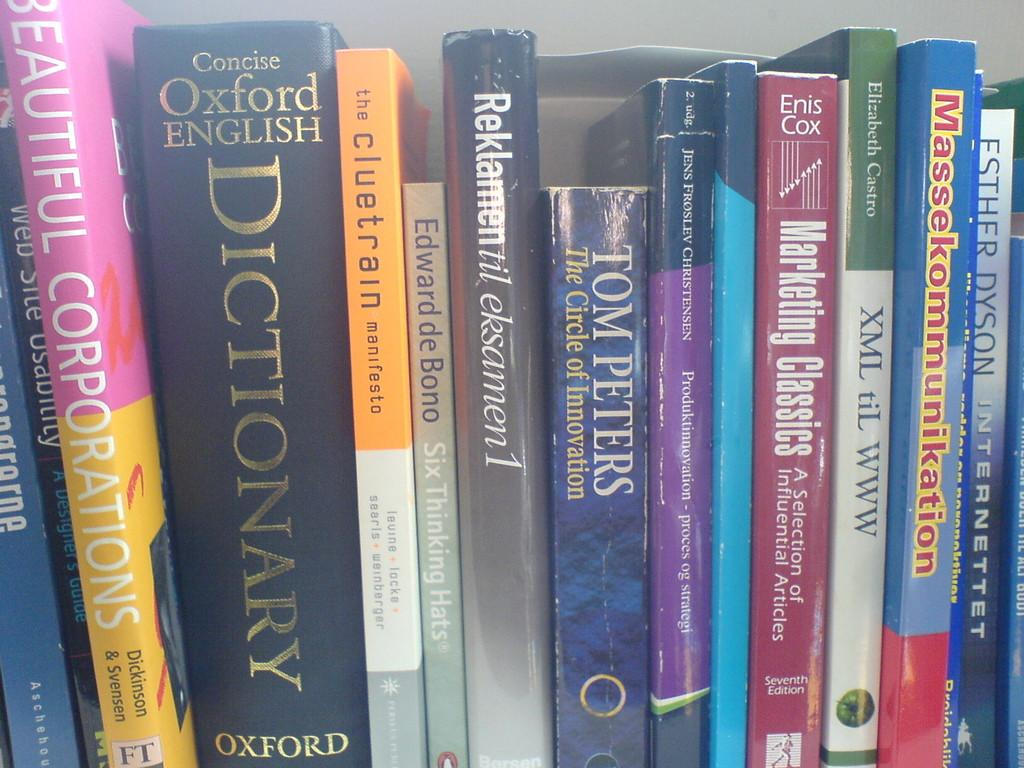<image>
Relay a brief, clear account of the picture shown. Several books stacked side by side with teh oxford english dictionary being on of them. 